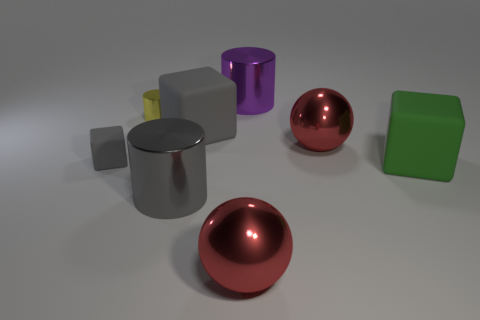There is a big block that is behind the gray object to the left of the metal object that is left of the big gray metallic cylinder; what color is it?
Give a very brief answer. Gray. What number of other things are the same size as the yellow thing?
Your answer should be compact. 1. What color is the small thing right of the tiny gray matte thing?
Keep it short and to the point. Yellow. How many other things are the same size as the green matte object?
Offer a terse response. 5. How big is the cylinder that is behind the large gray cylinder and to the left of the big purple shiny object?
Ensure brevity in your answer.  Small. Does the small matte cube have the same color as the metal cylinder in front of the small rubber block?
Provide a short and direct response. Yes. Is there a small gray matte thing that has the same shape as the green matte object?
Make the answer very short. Yes. How many things are either small objects or cylinders that are behind the yellow metallic cylinder?
Ensure brevity in your answer.  3. How many other things are the same material as the gray cylinder?
Provide a short and direct response. 4. What number of objects are big green matte cylinders or large red spheres?
Give a very brief answer. 2. 